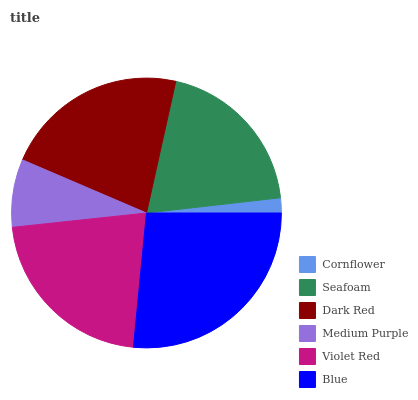Is Cornflower the minimum?
Answer yes or no. Yes. Is Blue the maximum?
Answer yes or no. Yes. Is Seafoam the minimum?
Answer yes or no. No. Is Seafoam the maximum?
Answer yes or no. No. Is Seafoam greater than Cornflower?
Answer yes or no. Yes. Is Cornflower less than Seafoam?
Answer yes or no. Yes. Is Cornflower greater than Seafoam?
Answer yes or no. No. Is Seafoam less than Cornflower?
Answer yes or no. No. Is Violet Red the high median?
Answer yes or no. Yes. Is Seafoam the low median?
Answer yes or no. Yes. Is Cornflower the high median?
Answer yes or no. No. Is Violet Red the low median?
Answer yes or no. No. 